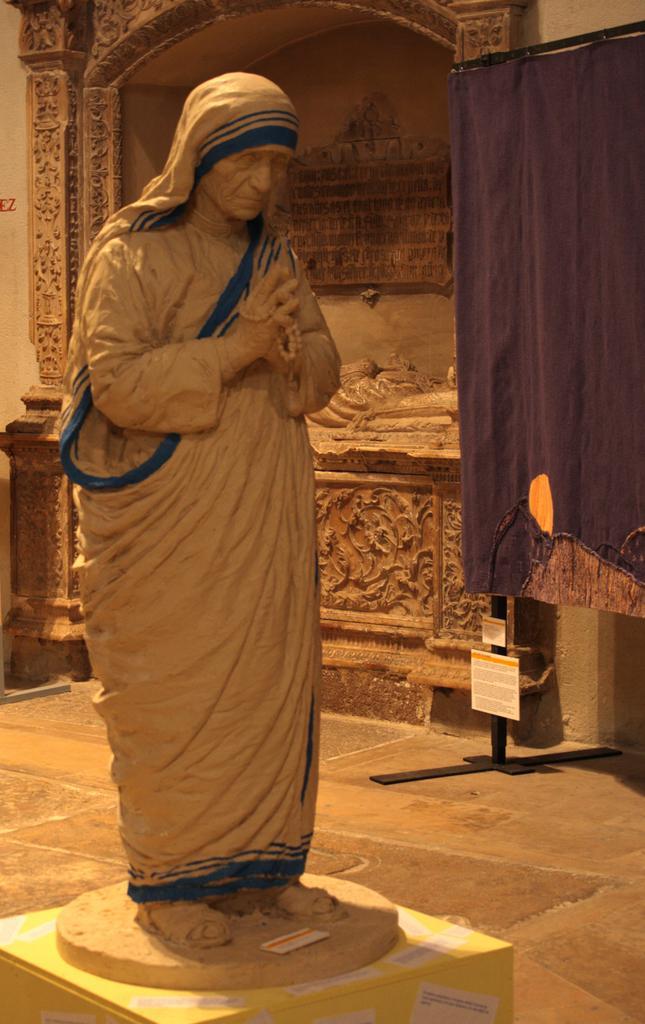Describe this image in one or two sentences. The picture there is a sculpture of Mother Teresa and behind her there is another construction and in the right side there is a blue cloth. 